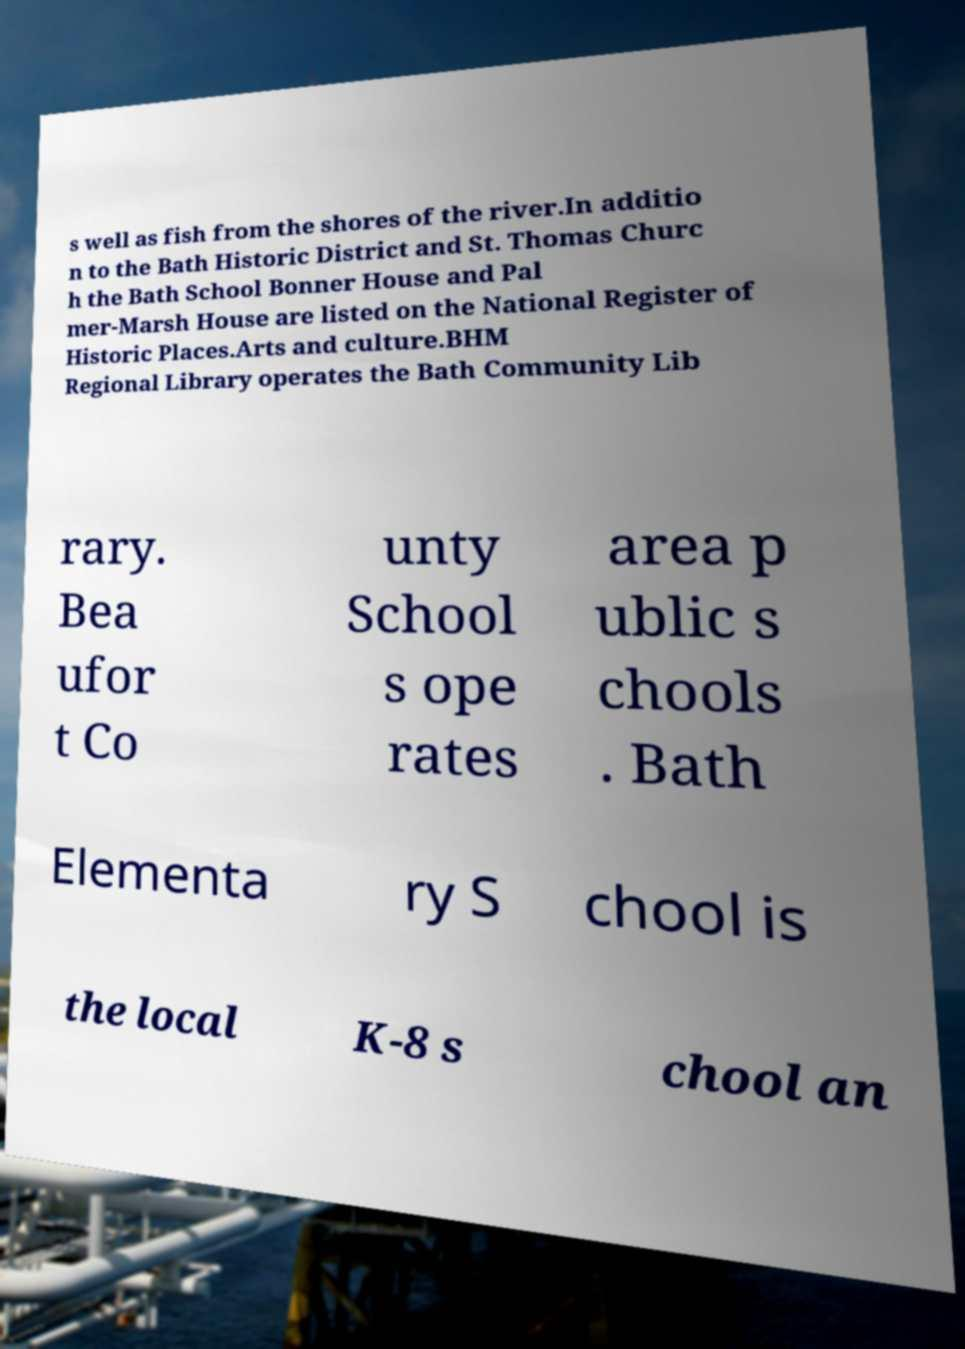Can you read and provide the text displayed in the image?This photo seems to have some interesting text. Can you extract and type it out for me? s well as fish from the shores of the river.In additio n to the Bath Historic District and St. Thomas Churc h the Bath School Bonner House and Pal mer-Marsh House are listed on the National Register of Historic Places.Arts and culture.BHM Regional Library operates the Bath Community Lib rary. Bea ufor t Co unty School s ope rates area p ublic s chools . Bath Elementa ry S chool is the local K-8 s chool an 